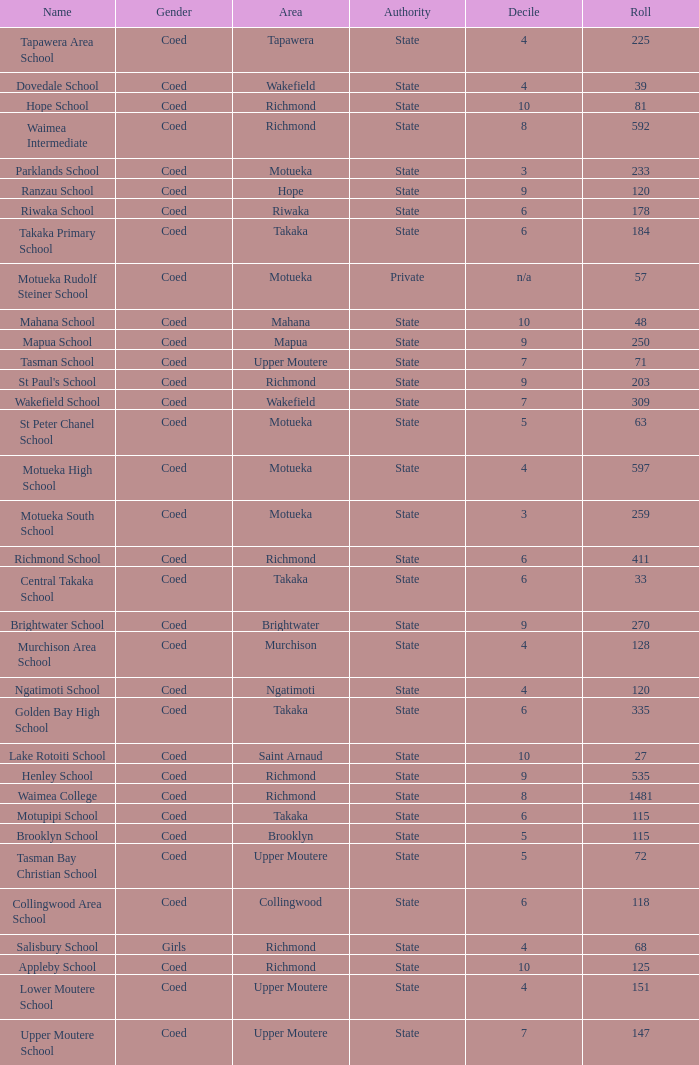What area is Central Takaka School in? Takaka. 